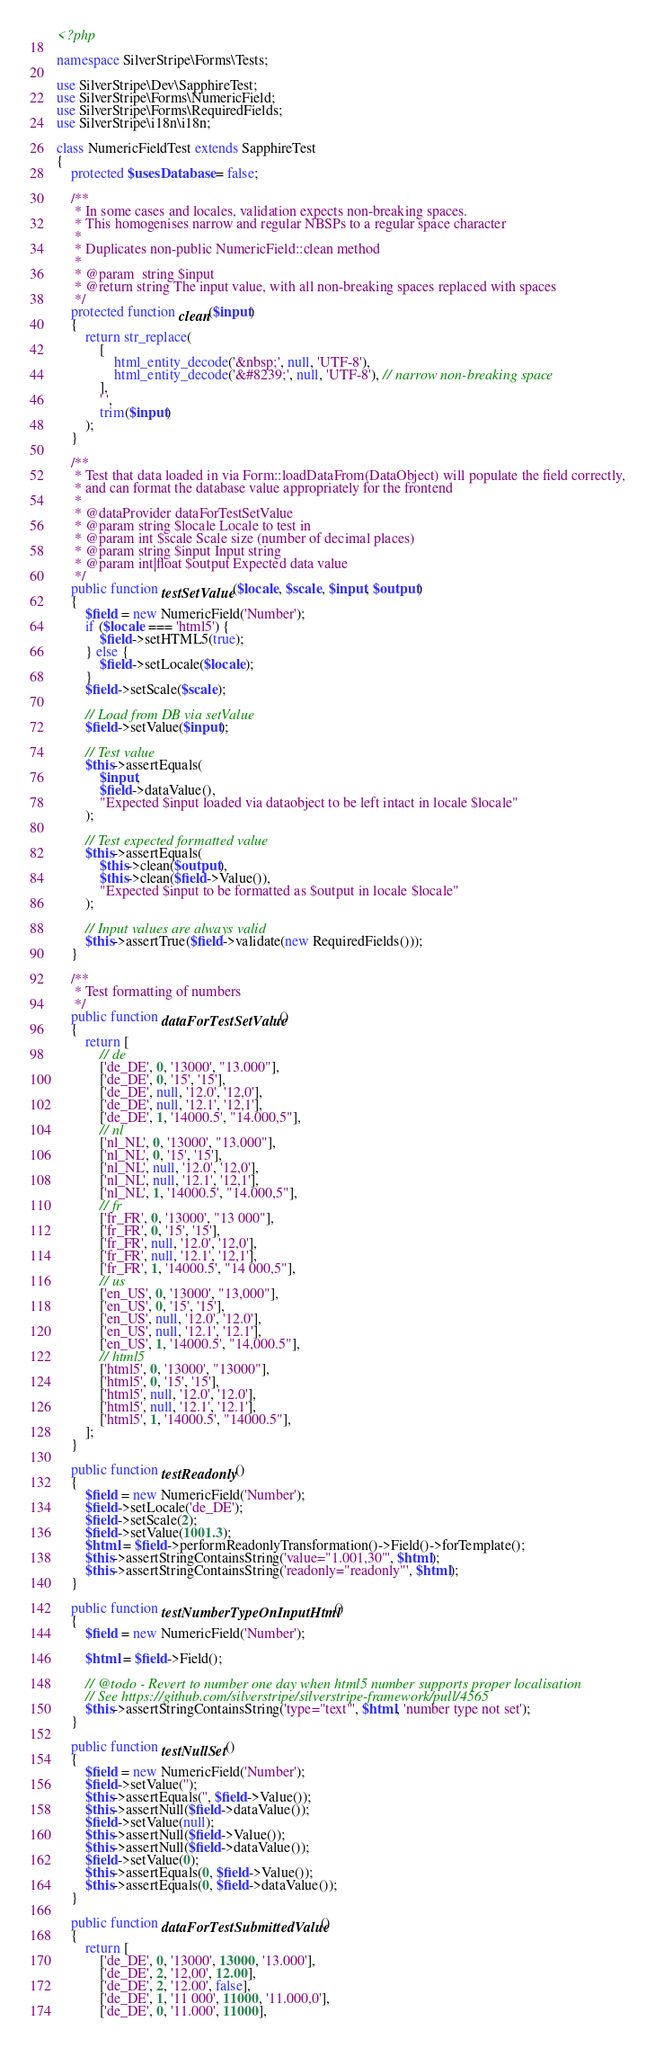Convert code to text. <code><loc_0><loc_0><loc_500><loc_500><_PHP_><?php

namespace SilverStripe\Forms\Tests;

use SilverStripe\Dev\SapphireTest;
use SilverStripe\Forms\NumericField;
use SilverStripe\Forms\RequiredFields;
use SilverStripe\i18n\i18n;

class NumericFieldTest extends SapphireTest
{
    protected $usesDatabase = false;

    /**
     * In some cases and locales, validation expects non-breaking spaces.
     * This homogenises narrow and regular NBSPs to a regular space character
     *
     * Duplicates non-public NumericField::clean method
     *
     * @param  string $input
     * @return string The input value, with all non-breaking spaces replaced with spaces
     */
    protected function clean($input)
    {
        return str_replace(
            [
                html_entity_decode('&nbsp;', null, 'UTF-8'),
                html_entity_decode('&#8239;', null, 'UTF-8'), // narrow non-breaking space
            ],
            ' ',
            trim($input)
        );
    }

    /**
     * Test that data loaded in via Form::loadDataFrom(DataObject) will populate the field correctly,
     * and can format the database value appropriately for the frontend
     *
     * @dataProvider dataForTestSetValue
     * @param string $locale Locale to test in
     * @param int $scale Scale size (number of decimal places)
     * @param string $input Input string
     * @param int|float $output Expected data value
     */
    public function testSetValue($locale, $scale, $input, $output)
    {
        $field = new NumericField('Number');
        if ($locale === 'html5') {
            $field->setHTML5(true);
        } else {
            $field->setLocale($locale);
        }
        $field->setScale($scale);

        // Load from DB via setValue
        $field->setValue($input);

        // Test value
        $this->assertEquals(
            $input,
            $field->dataValue(),
            "Expected $input loaded via dataobject to be left intact in locale $locale"
        );

        // Test expected formatted value
        $this->assertEquals(
            $this->clean($output),
            $this->clean($field->Value()),
            "Expected $input to be formatted as $output in locale $locale"
        );

        // Input values are always valid
        $this->assertTrue($field->validate(new RequiredFields()));
    }

    /**
     * Test formatting of numbers
     */
    public function dataForTestSetValue()
    {
        return [
            // de
            ['de_DE', 0, '13000', "13.000"],
            ['de_DE', 0, '15', '15'],
            ['de_DE', null, '12.0', '12,0'],
            ['de_DE', null, '12.1', '12,1'],
            ['de_DE', 1, '14000.5', "14.000,5"],
            // nl
            ['nl_NL', 0, '13000', "13.000"],
            ['nl_NL', 0, '15', '15'],
            ['nl_NL', null, '12.0', '12,0'],
            ['nl_NL', null, '12.1', '12,1'],
            ['nl_NL', 1, '14000.5', "14.000,5"],
            // fr
            ['fr_FR', 0, '13000', "13 000"],
            ['fr_FR', 0, '15', '15'],
            ['fr_FR', null, '12.0', '12,0'],
            ['fr_FR', null, '12.1', '12,1'],
            ['fr_FR', 1, '14000.5', "14 000,5"],
            // us
            ['en_US', 0, '13000', "13,000"],
            ['en_US', 0, '15', '15'],
            ['en_US', null, '12.0', '12.0'],
            ['en_US', null, '12.1', '12.1'],
            ['en_US', 1, '14000.5', "14,000.5"],
            // html5
            ['html5', 0, '13000', "13000"],
            ['html5', 0, '15', '15'],
            ['html5', null, '12.0', '12.0'],
            ['html5', null, '12.1', '12.1'],
            ['html5', 1, '14000.5', "14000.5"],
        ];
    }

    public function testReadonly()
    {
        $field = new NumericField('Number');
        $field->setLocale('de_DE');
        $field->setScale(2);
        $field->setValue(1001.3);
        $html = $field->performReadonlyTransformation()->Field()->forTemplate();
        $this->assertStringContainsString('value="1.001,30"', $html);
        $this->assertStringContainsString('readonly="readonly"', $html);
    }

    public function testNumberTypeOnInputHtml()
    {
        $field = new NumericField('Number');

        $html = $field->Field();

        // @todo - Revert to number one day when html5 number supports proper localisation
        // See https://github.com/silverstripe/silverstripe-framework/pull/4565
        $this->assertStringContainsString('type="text"', $html, 'number type not set');
    }

    public function testNullSet()
    {
        $field = new NumericField('Number');
        $field->setValue('');
        $this->assertEquals('', $field->Value());
        $this->assertNull($field->dataValue());
        $field->setValue(null);
        $this->assertNull($field->Value());
        $this->assertNull($field->dataValue());
        $field->setValue(0);
        $this->assertEquals(0, $field->Value());
        $this->assertEquals(0, $field->dataValue());
    }

    public function dataForTestSubmittedValue()
    {
        return [
            ['de_DE', 0, '13000', 13000, '13.000'],
            ['de_DE', 2, '12,00', 12.00],
            ['de_DE', 2, '12.00', false],
            ['de_DE', 1, '11 000', 11000, '11.000,0'],
            ['de_DE', 0, '11.000', 11000],</code> 